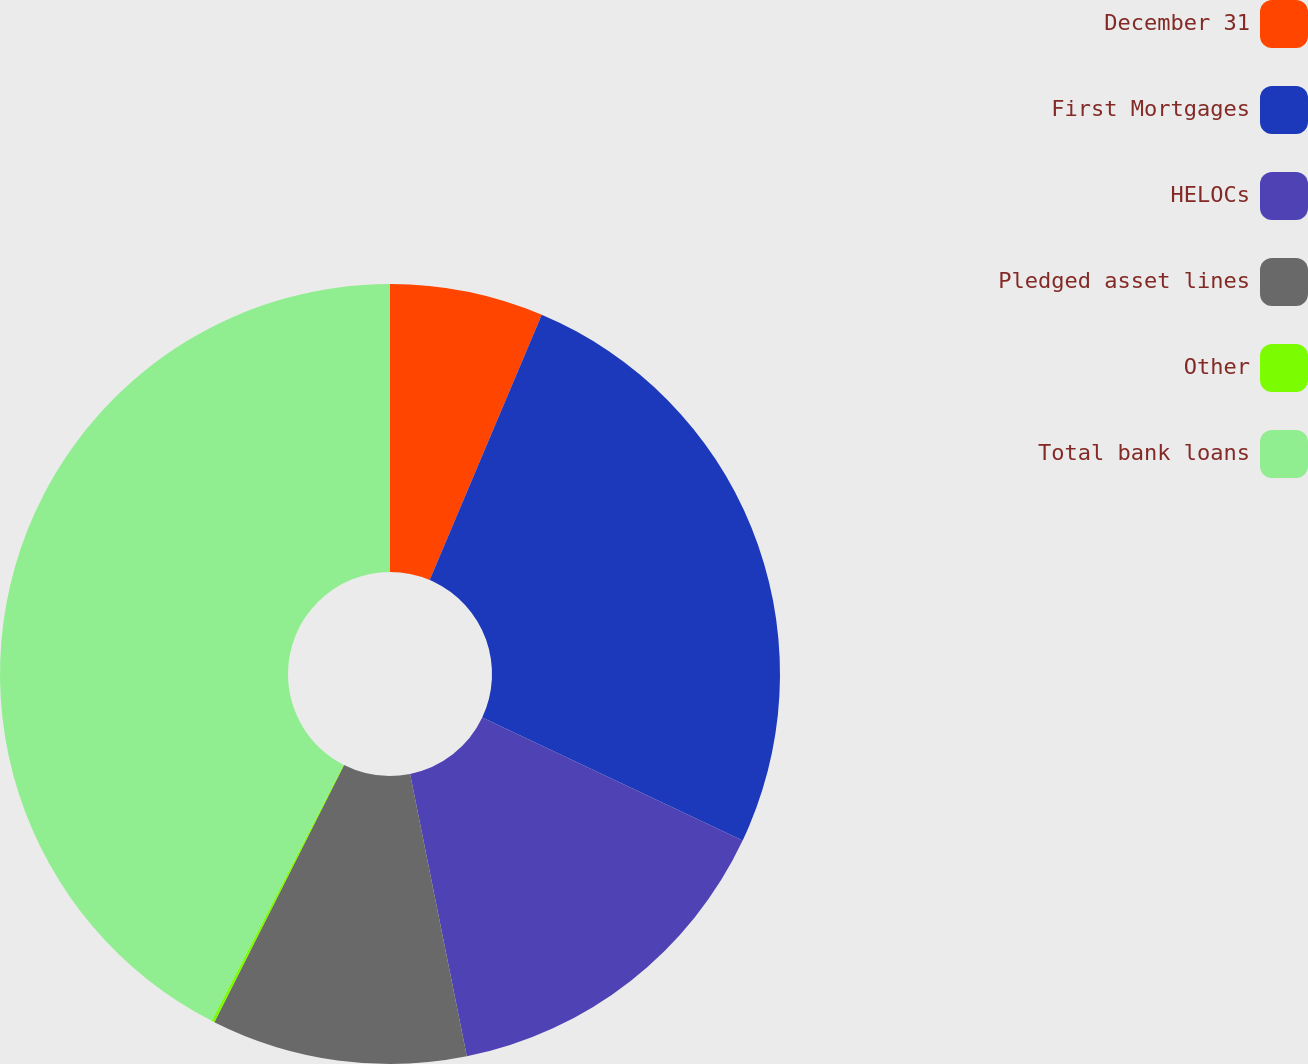Convert chart to OTSL. <chart><loc_0><loc_0><loc_500><loc_500><pie_chart><fcel>December 31<fcel>First Mortgages<fcel>HELOCs<fcel>Pledged asset lines<fcel>Other<fcel>Total bank loans<nl><fcel>6.36%<fcel>25.66%<fcel>14.82%<fcel>10.59%<fcel>0.12%<fcel>42.44%<nl></chart> 